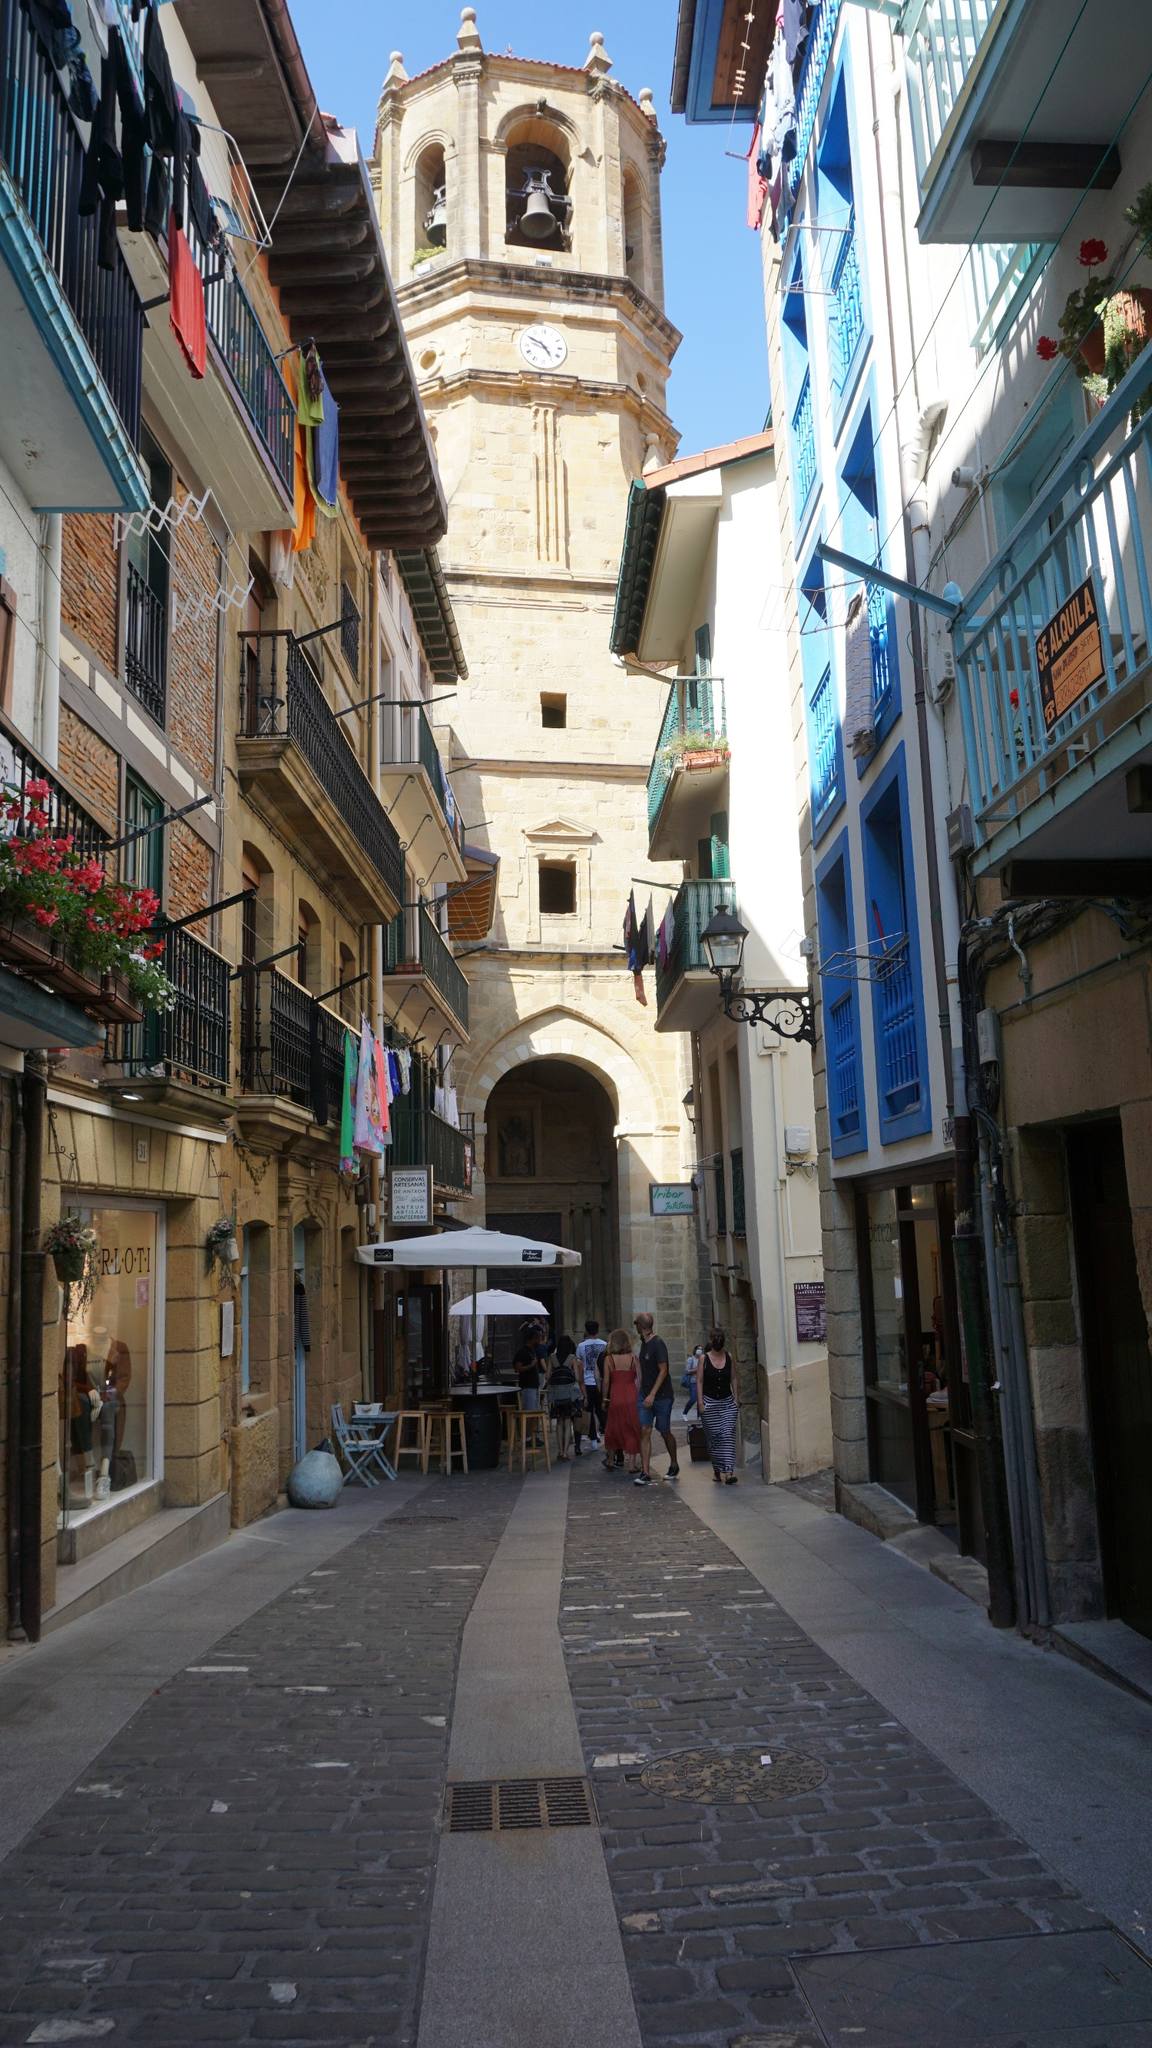What might be the cultural significance of this town's layout and architecture? The layout and architecture suggest a deep rootedness in historical and cultural values. Traditionally, European towns like this were designed with a central tower or belfry, serving as both a timekeeping and communal gathering point, reflecting the town's organization around communal and social functions. The narrow streets and close-knit buildings encouraged community interactions, which are fundamental aspects of cultural life in many European towns. Such structures and their arrangements are not only practical in terms of defense and space utilization but also promote a strong sense of community and craftsmanship that is passed down through generations. 